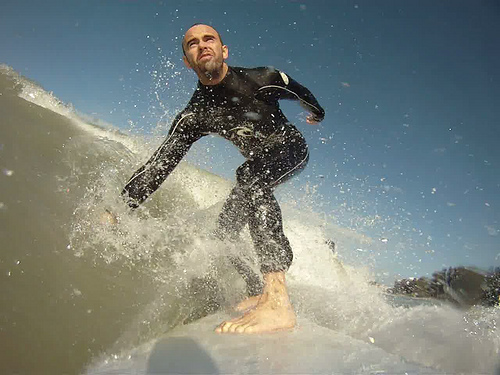Analyze the image in a comprehensive and detailed manner. This captivating image showcases a surfer intensely engaged in the act of surfing a wave. The surfer dons a sleek black wetsuit that securely fits from his neck down to his ankles. His posture and the position of his body evoke a sense of dynamic movement, as he balances and maneuvers expertly on his surfboard. The wetsuit not only highlights the contours and muscles of his body but also offers a stark contrast against the swirling white water. The image captures the raw power and grace of surfing, freezing a moment that is filled with energy and focus. 